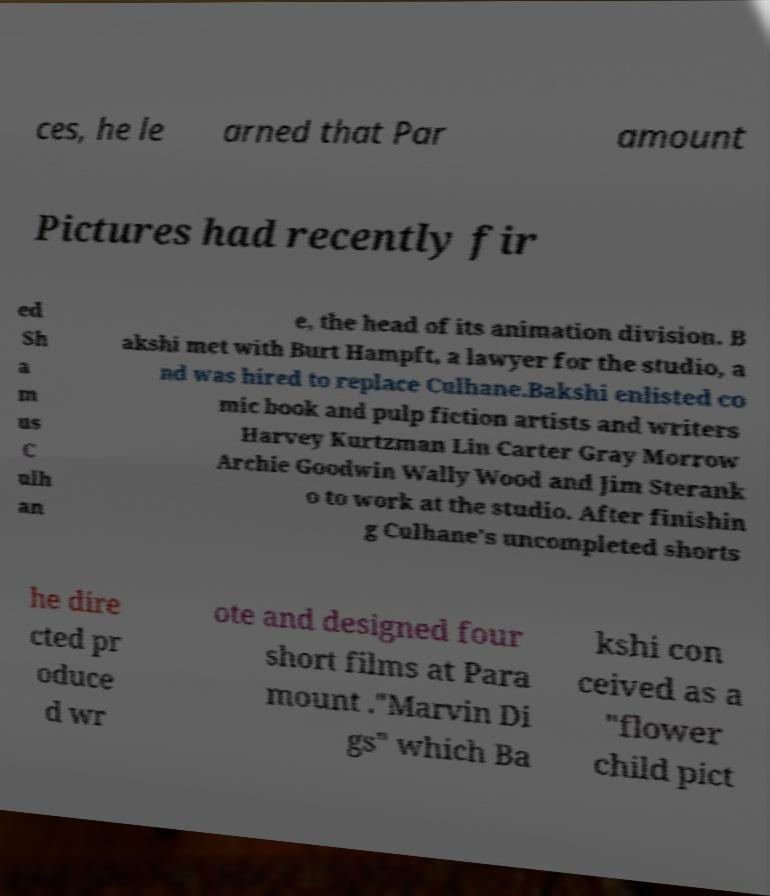Please identify and transcribe the text found in this image. ces, he le arned that Par amount Pictures had recently fir ed Sh a m us C ulh an e, the head of its animation division. B akshi met with Burt Hampft, a lawyer for the studio, a nd was hired to replace Culhane.Bakshi enlisted co mic book and pulp fiction artists and writers Harvey Kurtzman Lin Carter Gray Morrow Archie Goodwin Wally Wood and Jim Sterank o to work at the studio. After finishin g Culhane's uncompleted shorts he dire cted pr oduce d wr ote and designed four short films at Para mount ."Marvin Di gs" which Ba kshi con ceived as a "flower child pict 